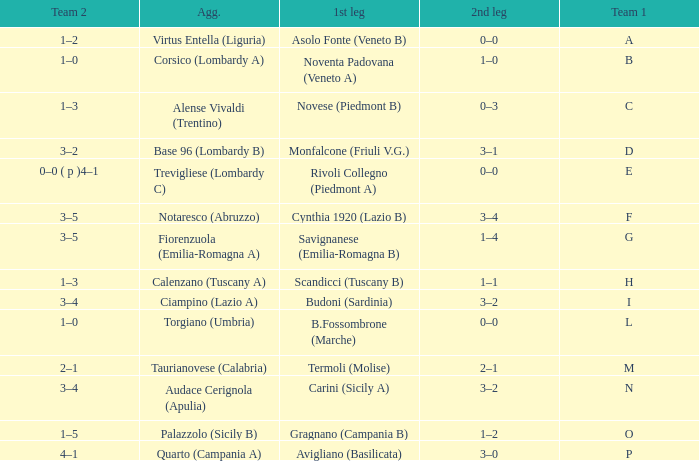What 1st leg has Alense Vivaldi (Trentino) as Agg.? Novese (Piedmont B). 